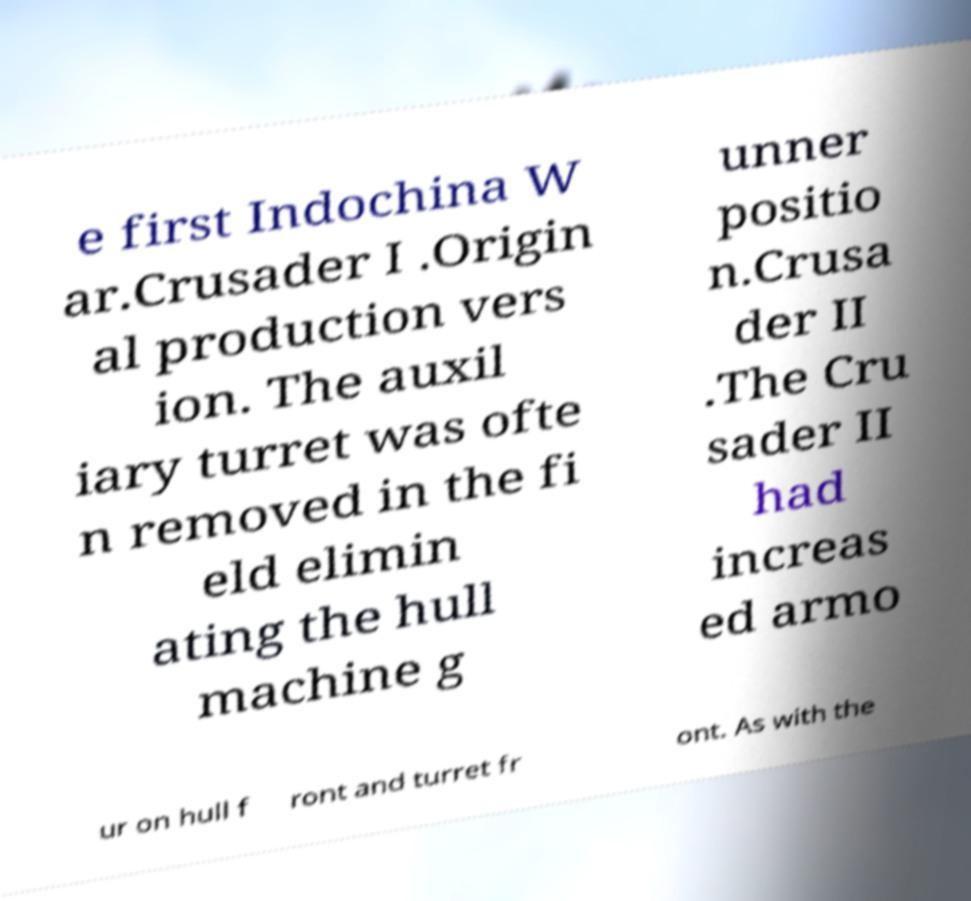There's text embedded in this image that I need extracted. Can you transcribe it verbatim? e first Indochina W ar.Crusader I .Origin al production vers ion. The auxil iary turret was ofte n removed in the fi eld elimin ating the hull machine g unner positio n.Crusa der II .The Cru sader II had increas ed armo ur on hull f ront and turret fr ont. As with the 